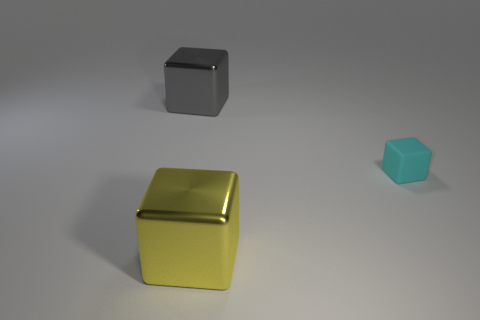Does the lighting in the image suggest a particular time of day or setting? The lighting in the image is soft and diffused, without any harsh shadows, which does not strongly suggest any specific time of day but indicates an evenly lit indoor setting or overcast outdoor environment. How does the color palette of the cubes affect their appearance? The color palette ranges from a neutral gray to a bright yellow and a muted blue, accentuating the differences in cube size and material, and creating a visual hierarchy among the cubes. 